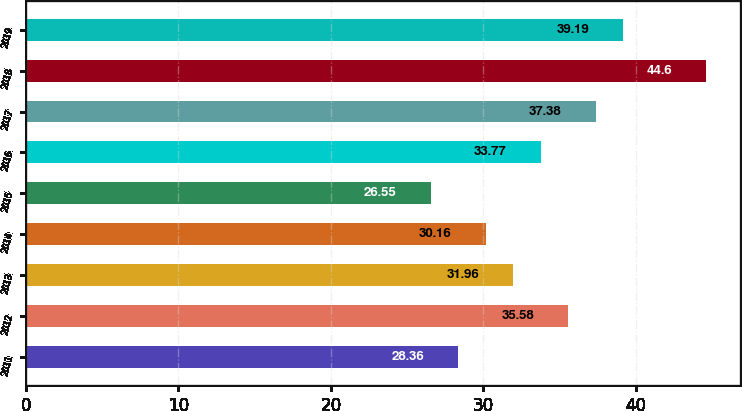Convert chart. <chart><loc_0><loc_0><loc_500><loc_500><bar_chart><fcel>2011<fcel>2012<fcel>2013<fcel>2014<fcel>2015<fcel>2016<fcel>2017<fcel>2018<fcel>2019<nl><fcel>28.36<fcel>35.58<fcel>31.96<fcel>30.16<fcel>26.55<fcel>33.77<fcel>37.38<fcel>44.6<fcel>39.19<nl></chart> 